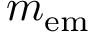Convert formula to latex. <formula><loc_0><loc_0><loc_500><loc_500>m _ { e m }</formula> 